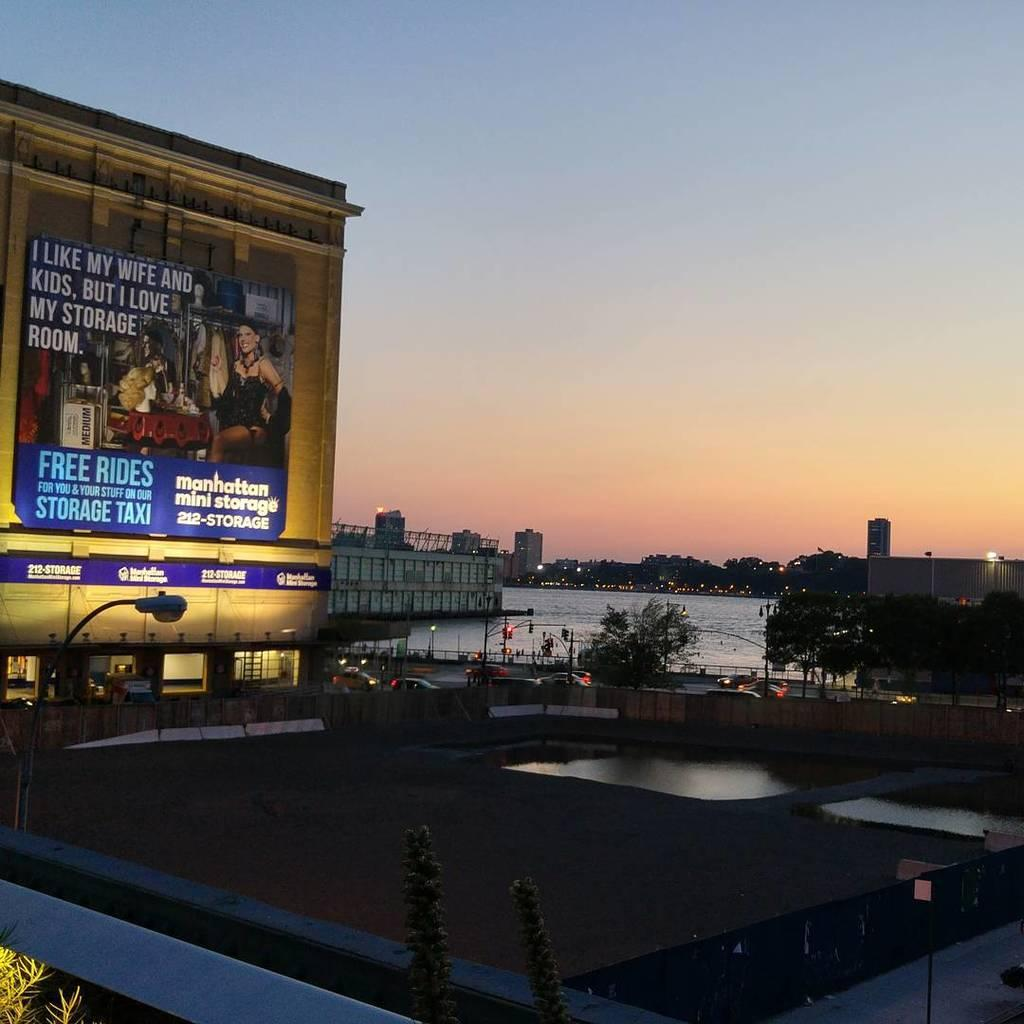Provide a one-sentence caption for the provided image. A view of the city with a large billboard advertising Manhattan Mini Storage. 